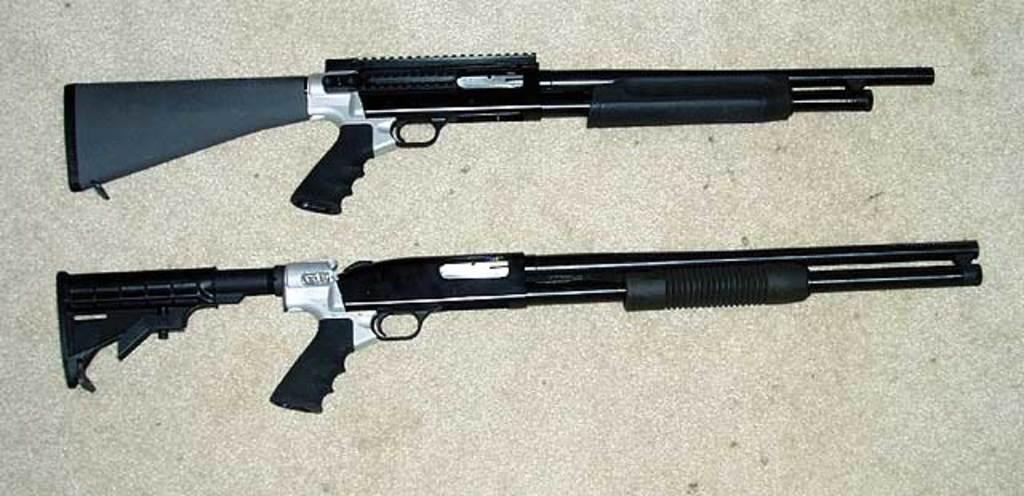How would you summarize this image in a sentence or two? In the center of the image, we can see guns on the table. 